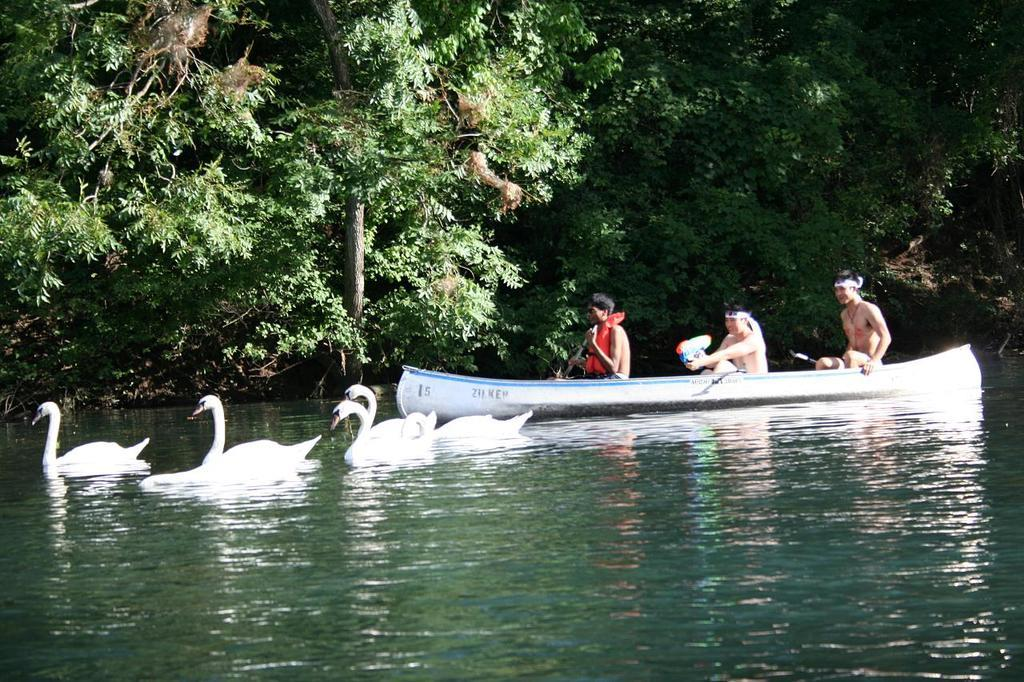What body of water is present in the image? There is a lake in the image. What animals can be seen in the lake? There are swans in the lake. What type of watercraft is in the lake? There is a boat in the lake. How many people are in the boat? There are three persons in the boat. What can be seen in the background of the image? There are trees in the background of the image. Where is the flame located in the image? There is no flame present in the image. What is the value of the cushion in the image? There is no cushion present in the image. 